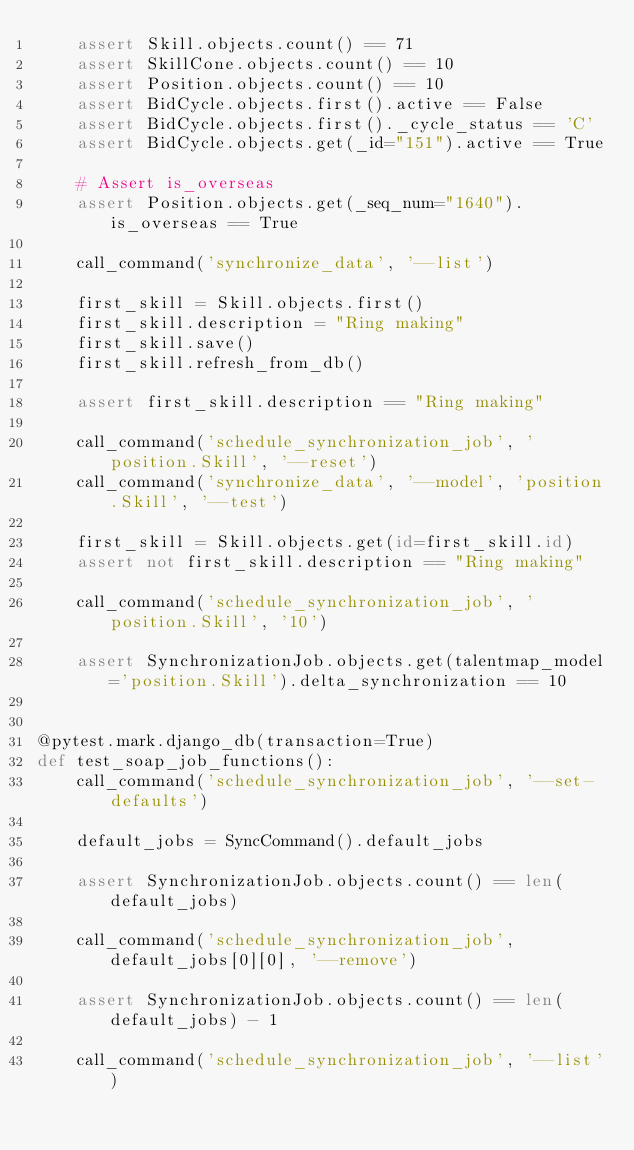Convert code to text. <code><loc_0><loc_0><loc_500><loc_500><_Python_>    assert Skill.objects.count() == 71
    assert SkillCone.objects.count() == 10
    assert Position.objects.count() == 10
    assert BidCycle.objects.first().active == False
    assert BidCycle.objects.first()._cycle_status == 'C'
    assert BidCycle.objects.get(_id="151").active == True

    # Assert is_overseas
    assert Position.objects.get(_seq_num="1640").is_overseas == True

    call_command('synchronize_data', '--list')

    first_skill = Skill.objects.first()
    first_skill.description = "Ring making"
    first_skill.save()
    first_skill.refresh_from_db()

    assert first_skill.description == "Ring making"

    call_command('schedule_synchronization_job', 'position.Skill', '--reset')
    call_command('synchronize_data', '--model', 'position.Skill', '--test')

    first_skill = Skill.objects.get(id=first_skill.id)
    assert not first_skill.description == "Ring making"

    call_command('schedule_synchronization_job', 'position.Skill', '10')

    assert SynchronizationJob.objects.get(talentmap_model='position.Skill').delta_synchronization == 10


@pytest.mark.django_db(transaction=True)
def test_soap_job_functions():
    call_command('schedule_synchronization_job', '--set-defaults')

    default_jobs = SyncCommand().default_jobs

    assert SynchronizationJob.objects.count() == len(default_jobs)

    call_command('schedule_synchronization_job', default_jobs[0][0], '--remove')

    assert SynchronizationJob.objects.count() == len(default_jobs) - 1

    call_command('schedule_synchronization_job', '--list')
</code> 